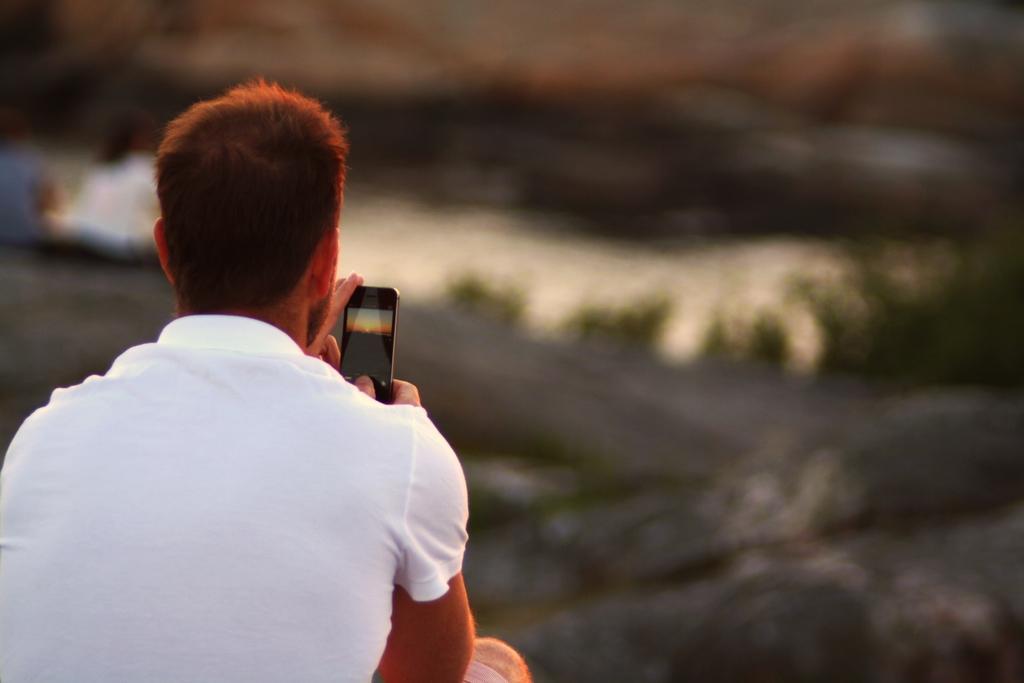Describe this image in one or two sentences. In this picture we can see a man holding a phone in his hand. Background is blurry. 